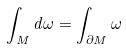<formula> <loc_0><loc_0><loc_500><loc_500>\int _ { M } d \omega = \int _ { \partial M } \omega</formula> 